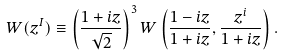<formula> <loc_0><loc_0><loc_500><loc_500>W ( z ^ { I } ) \equiv \left ( \frac { 1 + i z } { \sqrt { 2 } } \right ) ^ { 3 } W \left ( \frac { 1 - i z } { 1 + i z } , \frac { z ^ { i } } { 1 + i z } \right ) .</formula> 